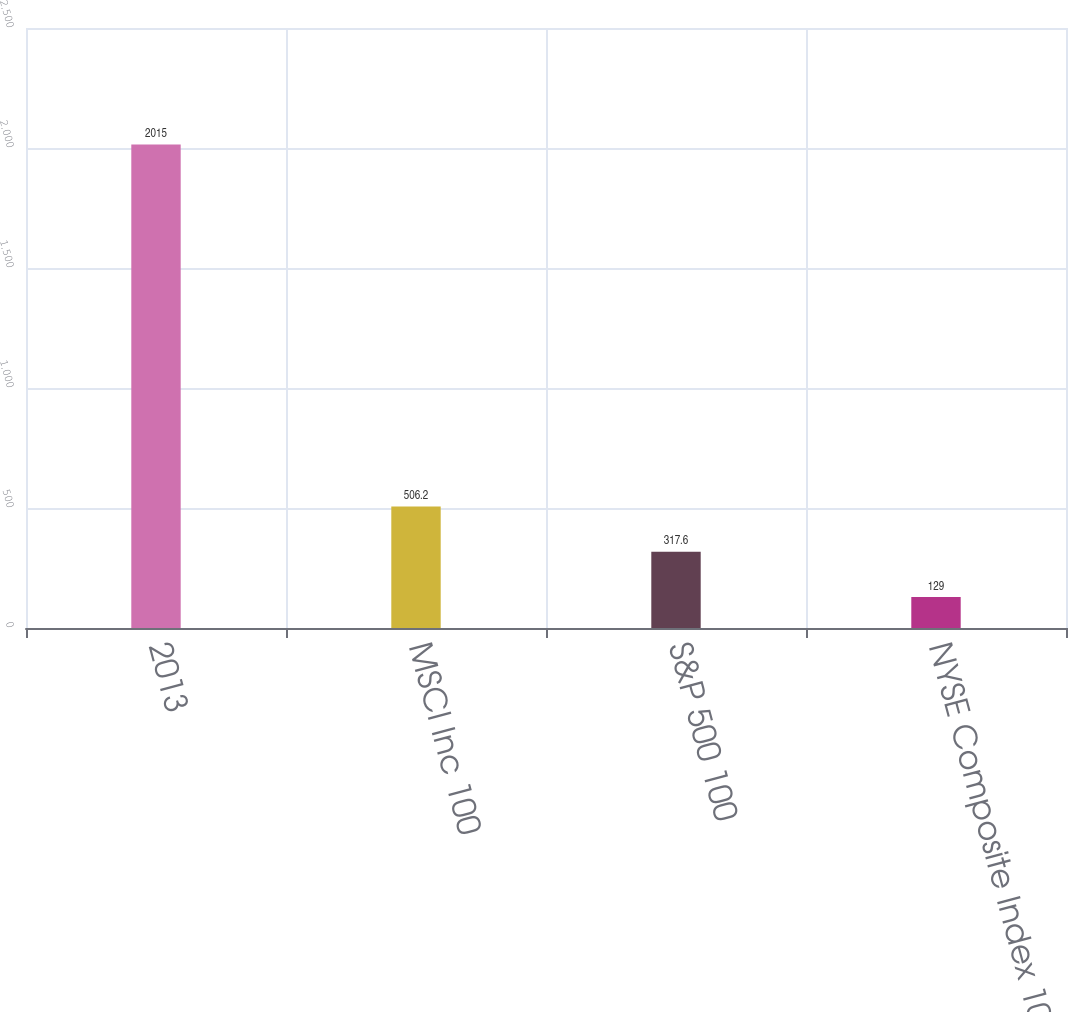<chart> <loc_0><loc_0><loc_500><loc_500><bar_chart><fcel>2013<fcel>MSCI Inc 100<fcel>S&P 500 100<fcel>NYSE Composite Index 100<nl><fcel>2015<fcel>506.2<fcel>317.6<fcel>129<nl></chart> 